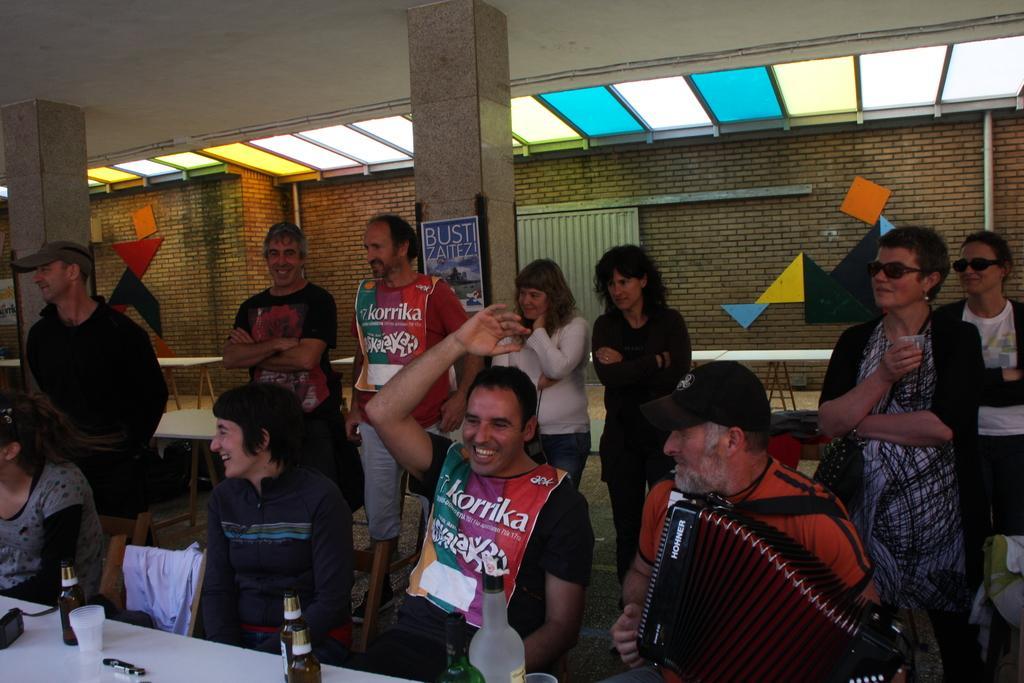Could you give a brief overview of what you see in this image? In this image we can see a few people, among them, some are sitting on the chairs, in front of them, we can see a table, on the table, there are bottles, glasses and some other objects, also we can see the pillars and tables, in the background, we can see some objects on the wall. 